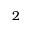<formula> <loc_0><loc_0><loc_500><loc_500>2</formula> 